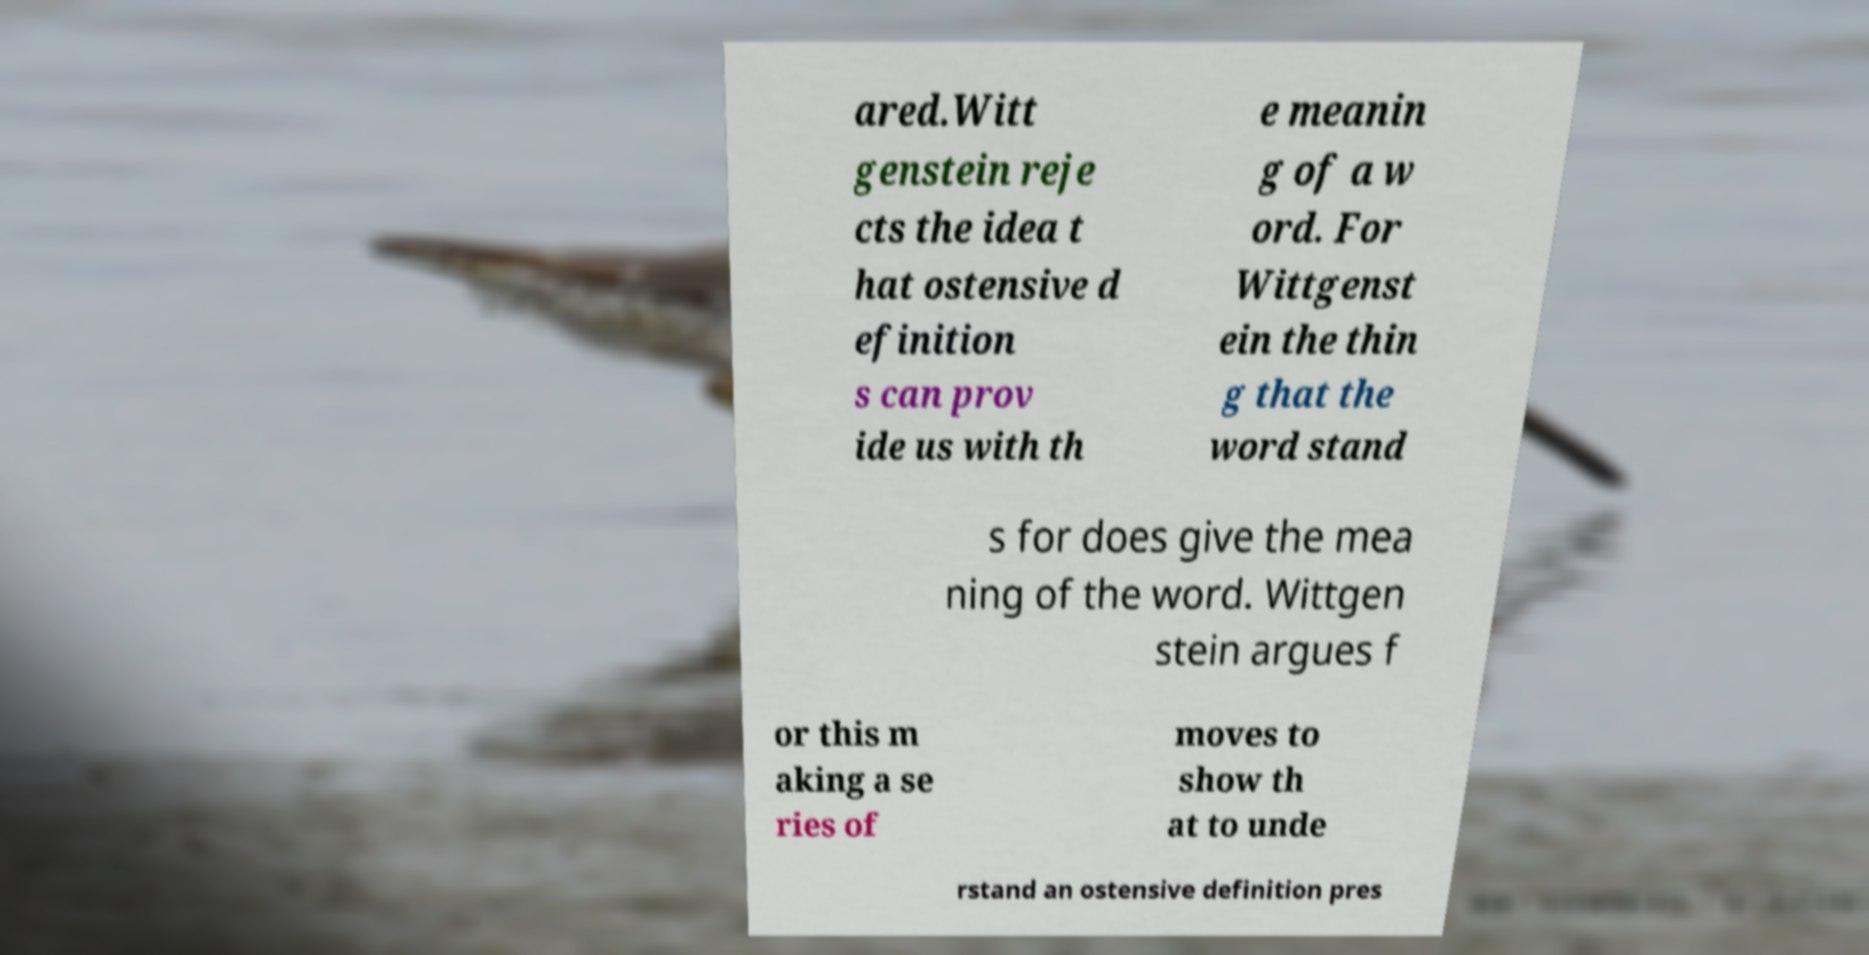I need the written content from this picture converted into text. Can you do that? ared.Witt genstein reje cts the idea t hat ostensive d efinition s can prov ide us with th e meanin g of a w ord. For Wittgenst ein the thin g that the word stand s for does give the mea ning of the word. Wittgen stein argues f or this m aking a se ries of moves to show th at to unde rstand an ostensive definition pres 